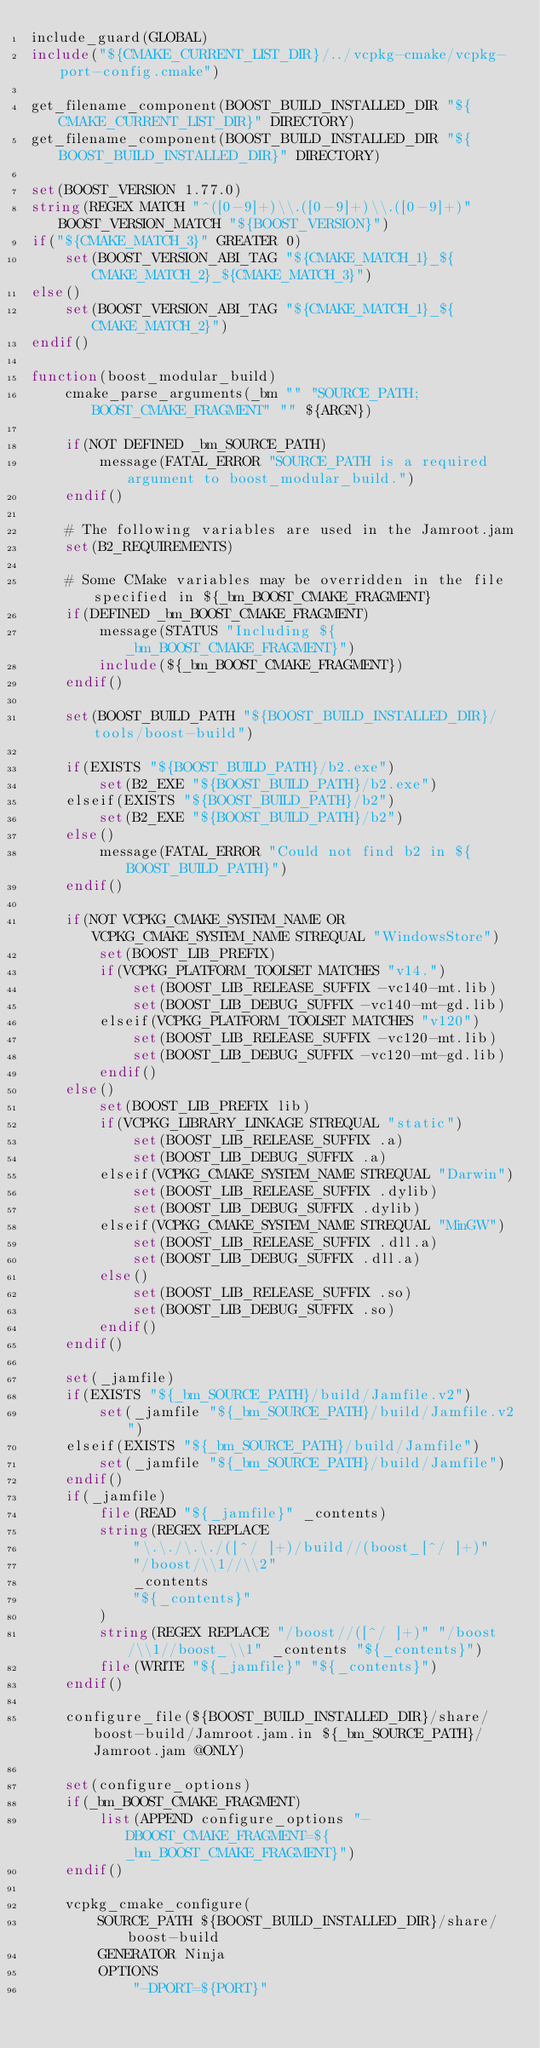<code> <loc_0><loc_0><loc_500><loc_500><_CMake_>include_guard(GLOBAL)
include("${CMAKE_CURRENT_LIST_DIR}/../vcpkg-cmake/vcpkg-port-config.cmake")

get_filename_component(BOOST_BUILD_INSTALLED_DIR "${CMAKE_CURRENT_LIST_DIR}" DIRECTORY)
get_filename_component(BOOST_BUILD_INSTALLED_DIR "${BOOST_BUILD_INSTALLED_DIR}" DIRECTORY)

set(BOOST_VERSION 1.77.0)
string(REGEX MATCH "^([0-9]+)\\.([0-9]+)\\.([0-9]+)" BOOST_VERSION_MATCH "${BOOST_VERSION}")
if("${CMAKE_MATCH_3}" GREATER 0)
    set(BOOST_VERSION_ABI_TAG "${CMAKE_MATCH_1}_${CMAKE_MATCH_2}_${CMAKE_MATCH_3}")
else()
    set(BOOST_VERSION_ABI_TAG "${CMAKE_MATCH_1}_${CMAKE_MATCH_2}")
endif()

function(boost_modular_build)
    cmake_parse_arguments(_bm "" "SOURCE_PATH;BOOST_CMAKE_FRAGMENT" "" ${ARGN})

    if(NOT DEFINED _bm_SOURCE_PATH)
        message(FATAL_ERROR "SOURCE_PATH is a required argument to boost_modular_build.")
    endif()

    # The following variables are used in the Jamroot.jam
    set(B2_REQUIREMENTS)

    # Some CMake variables may be overridden in the file specified in ${_bm_BOOST_CMAKE_FRAGMENT}
    if(DEFINED _bm_BOOST_CMAKE_FRAGMENT)
        message(STATUS "Including ${_bm_BOOST_CMAKE_FRAGMENT}")
        include(${_bm_BOOST_CMAKE_FRAGMENT})
    endif()

    set(BOOST_BUILD_PATH "${BOOST_BUILD_INSTALLED_DIR}/tools/boost-build")

    if(EXISTS "${BOOST_BUILD_PATH}/b2.exe")
        set(B2_EXE "${BOOST_BUILD_PATH}/b2.exe")
    elseif(EXISTS "${BOOST_BUILD_PATH}/b2")
        set(B2_EXE "${BOOST_BUILD_PATH}/b2")
    else()
        message(FATAL_ERROR "Could not find b2 in ${BOOST_BUILD_PATH}")
    endif()

    if(NOT VCPKG_CMAKE_SYSTEM_NAME OR VCPKG_CMAKE_SYSTEM_NAME STREQUAL "WindowsStore")
        set(BOOST_LIB_PREFIX)
        if(VCPKG_PLATFORM_TOOLSET MATCHES "v14.")
            set(BOOST_LIB_RELEASE_SUFFIX -vc140-mt.lib)
            set(BOOST_LIB_DEBUG_SUFFIX -vc140-mt-gd.lib)
        elseif(VCPKG_PLATFORM_TOOLSET MATCHES "v120")
            set(BOOST_LIB_RELEASE_SUFFIX -vc120-mt.lib)
            set(BOOST_LIB_DEBUG_SUFFIX -vc120-mt-gd.lib)
        endif()
    else()
        set(BOOST_LIB_PREFIX lib)
        if(VCPKG_LIBRARY_LINKAGE STREQUAL "static")
            set(BOOST_LIB_RELEASE_SUFFIX .a)
            set(BOOST_LIB_DEBUG_SUFFIX .a)
        elseif(VCPKG_CMAKE_SYSTEM_NAME STREQUAL "Darwin")
            set(BOOST_LIB_RELEASE_SUFFIX .dylib)
            set(BOOST_LIB_DEBUG_SUFFIX .dylib)
        elseif(VCPKG_CMAKE_SYSTEM_NAME STREQUAL "MinGW")
            set(BOOST_LIB_RELEASE_SUFFIX .dll.a)
            set(BOOST_LIB_DEBUG_SUFFIX .dll.a)
        else()
            set(BOOST_LIB_RELEASE_SUFFIX .so)
            set(BOOST_LIB_DEBUG_SUFFIX .so)
        endif()
    endif()

    set(_jamfile)
    if(EXISTS "${_bm_SOURCE_PATH}/build/Jamfile.v2")
        set(_jamfile "${_bm_SOURCE_PATH}/build/Jamfile.v2")
    elseif(EXISTS "${_bm_SOURCE_PATH}/build/Jamfile")
        set(_jamfile "${_bm_SOURCE_PATH}/build/Jamfile")
    endif()
    if(_jamfile)
        file(READ "${_jamfile}" _contents)
        string(REGEX REPLACE
            "\.\./\.\./([^/ ]+)/build//(boost_[^/ ]+)"
            "/boost/\\1//\\2"
            _contents
            "${_contents}"
        )
        string(REGEX REPLACE "/boost//([^/ ]+)" "/boost/\\1//boost_\\1" _contents "${_contents}")
        file(WRITE "${_jamfile}" "${_contents}")
    endif()

    configure_file(${BOOST_BUILD_INSTALLED_DIR}/share/boost-build/Jamroot.jam.in ${_bm_SOURCE_PATH}/Jamroot.jam @ONLY)

    set(configure_options)
    if(_bm_BOOST_CMAKE_FRAGMENT)
        list(APPEND configure_options "-DBOOST_CMAKE_FRAGMENT=${_bm_BOOST_CMAKE_FRAGMENT}")
    endif()

    vcpkg_cmake_configure(
        SOURCE_PATH ${BOOST_BUILD_INSTALLED_DIR}/share/boost-build
        GENERATOR Ninja
        OPTIONS
            "-DPORT=${PORT}"</code> 